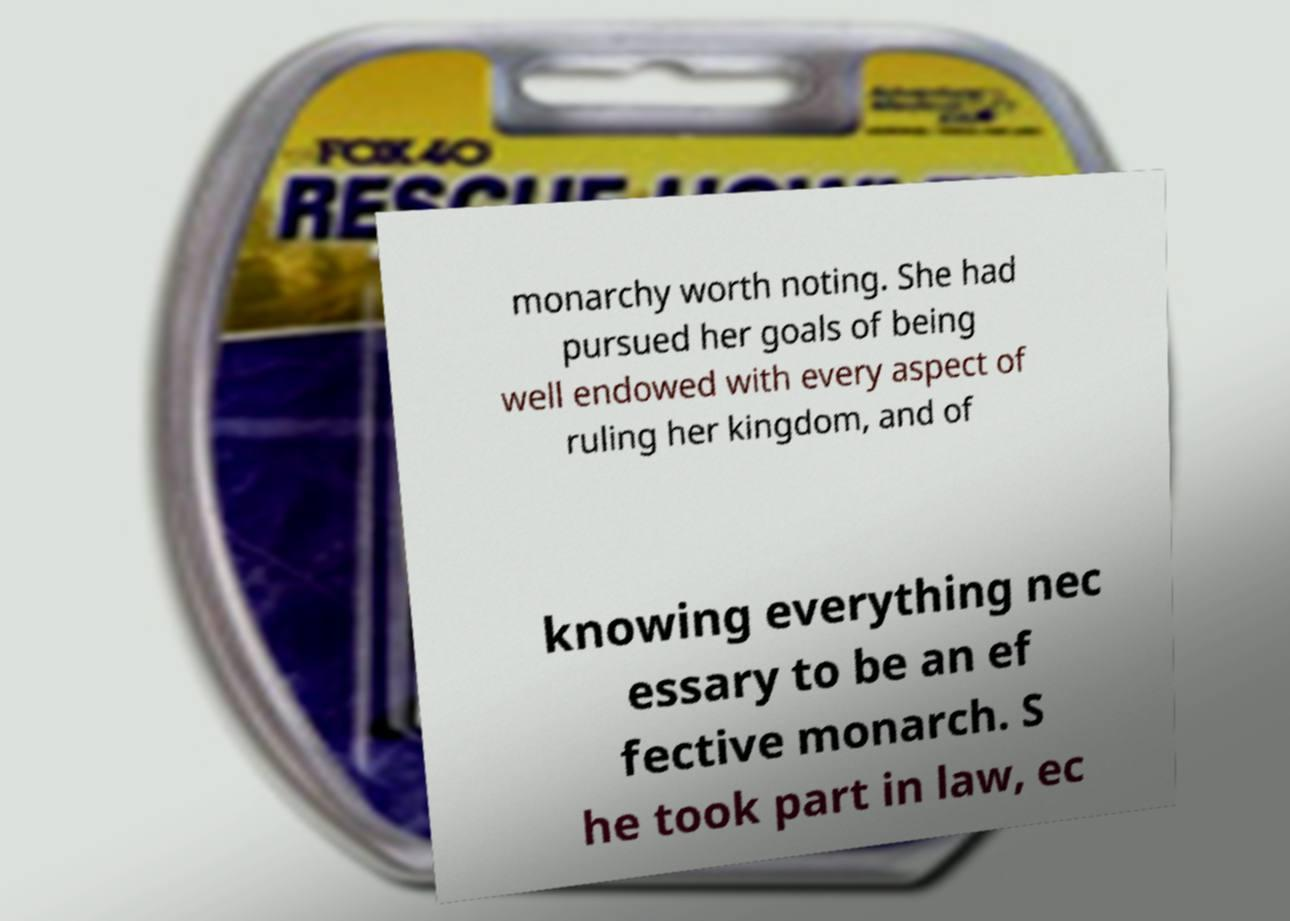I need the written content from this picture converted into text. Can you do that? monarchy worth noting. She had pursued her goals of being well endowed with every aspect of ruling her kingdom, and of knowing everything nec essary to be an ef fective monarch. S he took part in law, ec 